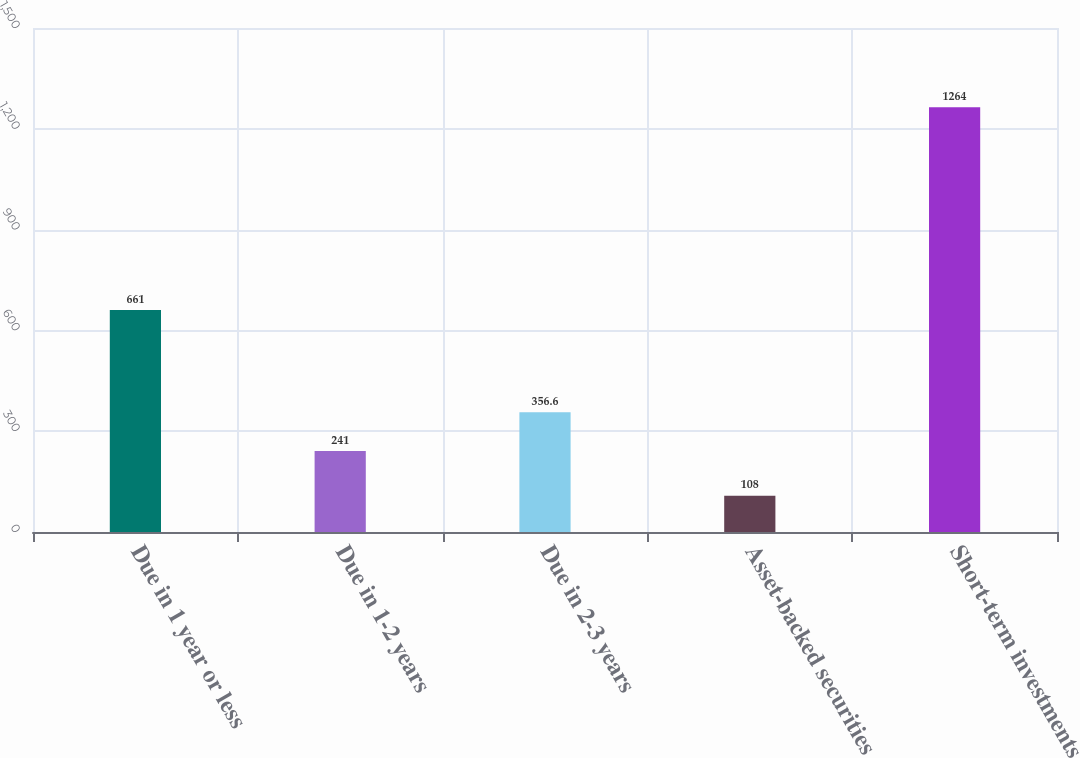Convert chart. <chart><loc_0><loc_0><loc_500><loc_500><bar_chart><fcel>Due in 1 year or less<fcel>Due in 1-2 years<fcel>Due in 2-3 years<fcel>Asset-backed securities<fcel>Short-term investments<nl><fcel>661<fcel>241<fcel>356.6<fcel>108<fcel>1264<nl></chart> 